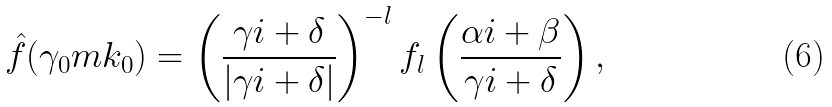Convert formula to latex. <formula><loc_0><loc_0><loc_500><loc_500>\hat { f } ( \gamma _ { 0 } m k _ { 0 } ) = \left ( \frac { \gamma i + \delta } { | \gamma i + \delta | } \right ) ^ { - l } f _ { l } \left ( \frac { \alpha i + \beta } { \gamma i + \delta } \right ) ,</formula> 